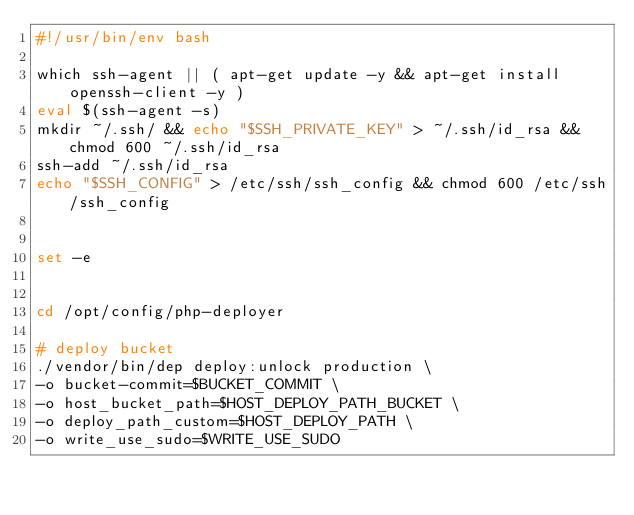Convert code to text. <code><loc_0><loc_0><loc_500><loc_500><_Bash_>#!/usr/bin/env bash

which ssh-agent || ( apt-get update -y && apt-get install openssh-client -y )
eval $(ssh-agent -s)
mkdir ~/.ssh/ && echo "$SSH_PRIVATE_KEY" > ~/.ssh/id_rsa && chmod 600 ~/.ssh/id_rsa
ssh-add ~/.ssh/id_rsa
echo "$SSH_CONFIG" > /etc/ssh/ssh_config && chmod 600 /etc/ssh/ssh_config


set -e


cd /opt/config/php-deployer

# deploy bucket
./vendor/bin/dep deploy:unlock production \
-o bucket-commit=$BUCKET_COMMIT \
-o host_bucket_path=$HOST_DEPLOY_PATH_BUCKET \
-o deploy_path_custom=$HOST_DEPLOY_PATH \
-o write_use_sudo=$WRITE_USE_SUDO
</code> 